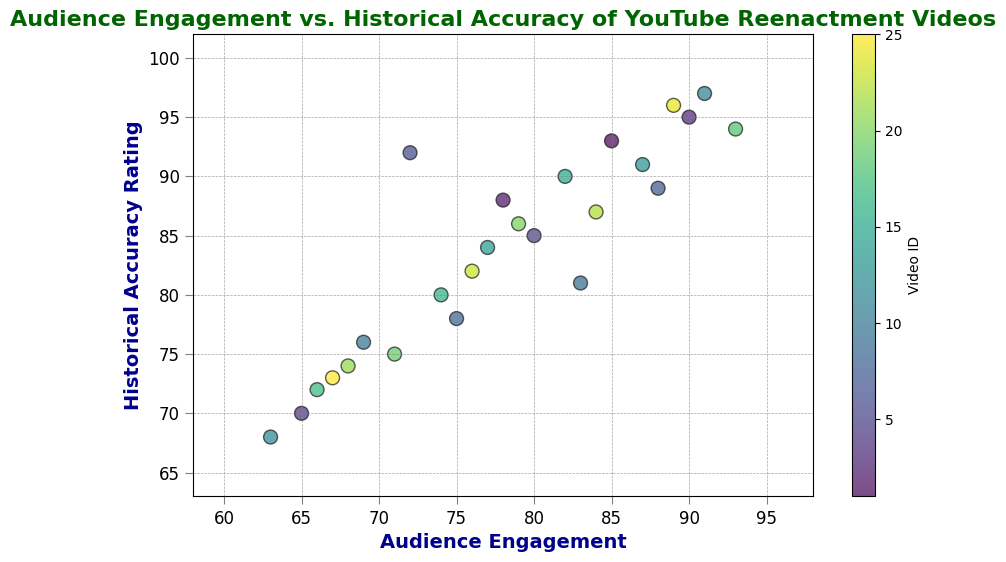Which video has the highest audience engagement? To find the video with the highest audience engagement, look for the point farthest to the right on the horizontal axis. Video 18 has the highest audience engagement at 93.
Answer: Video 18 Which video has the lowest historical accuracy rating? Look for the point closest to the bottom of the vertical axis. Video 12 has the lowest historical accuracy rating at 68.
Answer: Video 12 What's the average historical accuracy rating of videos with an audience engagement of 80 or higher? Identify the videos with an audience engagement of 80 or higher and then calculate the average historical accuracy rating of these videos. Videos 1, 3, 5, 7, 11, 13, 15, 18, 20, 22, 24 have ratings of 93, 95, 85, 89, 97, 91, 90, 94, 86, 87, 96 respectively: (93 + 95 + 85 + 89 + 97 + 91 + 90 + 94 + 86 + 87 + 96) / 11 ≈ 91
Answer: 91 How many videos have both audience engagement and historical accuracy rating greater than 90? Count the points in the top right quadrant where both values on the axes are greater than 90. Videos 3, 11, 18, and 24 have both values greater than 90. Thus, there are 4 such videos.
Answer: 4 Is there a clear trend visible between audience engagement and historical accuracy rating? Check the overall pattern of the scatter plot points. It appears that generally, as one value increases, the other also tends to increase, indicating a positive correlation between audience engagement and historical accuracy rating.
Answer: Yes What are the audience engagement and historical accuracy rating range for the majority of videos? Observing the concentration of points in the scatter plot, most videos tend to lie within the range of approximately 65-90 for audience engagement and 70-95 for historical accuracy rating.
Answer: 65-90 for engagement, 70-95 for accuracy Which video has the highest historical accuracy rating but not the highest audience engagement? Identify the video with the highest historical accuracy rating and then check if it has the highest audience engagement. Video 11 has the highest accuracy rating at 97 but its audience engagement is 91. Video 18 has the highest engagement at 93.
Answer: Video 11 What is the historical accuracy rating for the video with the lowest audience engagement? Find the point closest to the left on the horizontal axis and read its vertical value. Video 12 has the lowest audience engagement at 63 and its historical accuracy rating is 68.
Answer: 68 Does any video with an audience engagement less than 70 have a historical accuracy rating greater than 80? Check the points left of 70 on the horizontal axis and see if any of their vertical values exceed 80. No video with an engagement below 70 has an accuracy rating above 80.
Answer: No What is the difference in historical accuracy rating between video 1 and video 4? Find the historical accuracy ratings of video 1 and video 4, then calculate the difference. Video 1 has a rating of 93, and video 4 has a rating of 70. The difference is 93 - 70 = 23.
Answer: 23 